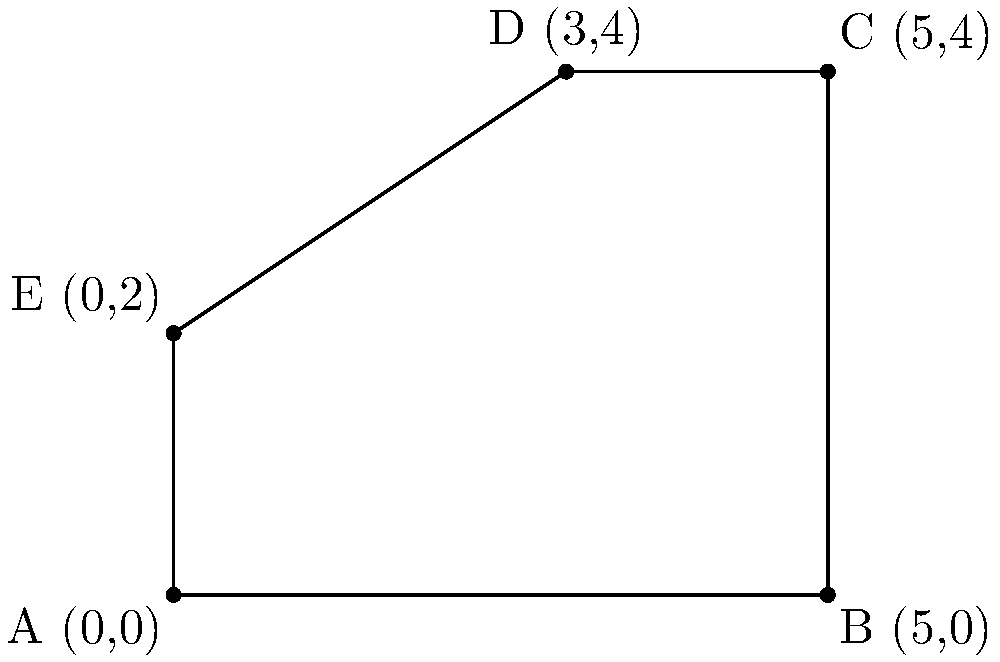As a freelance photographer, you've experienced water damage in your home studio. The insurance adjuster has provided you with a diagram of the affected area, represented by the polygon ABCDE. Calculate the total area of water damage in square meters given the following coordinates:
A(0,0), B(5,0), C(5,4), D(3,4), and E(0,2). To calculate the area of the irregular polygon ABCDE, we can divide it into two parts: a rectangle and a triangle. Let's approach this step-by-step:

1. Identify the rectangle:
   The rectangle is formed by points A, B, D, and the point (3,0) on the x-axis.
   Area of rectangle = length × width
   = 3 × 4 = 12 sq meters

2. Identify the remaining triangle:
   The triangle is formed by points (3,0), B(5,0), and C(5,4).
   
3. Calculate the area of the triangle:
   Area of triangle = $\frac{1}{2}$ × base × height
   Base = 5 - 3 = 2 meters
   Height = 4 meters
   Area of triangle = $\frac{1}{2}$ × 2 × 4 = 4 sq meters

4. Calculate the area of the trapezoid AEDC:
   We can use the formula: Area = $\frac{1}{2}(b_1 + b_2)h$
   where $b_1$ and $b_2$ are the parallel sides and h is the height.
   $b_1$ = 3 (length of DC)
   $b_2$ = 2 (length of AE)
   h = 4 (height from A to D)
   Area of trapezoid = $\frac{1}{2}(3 + 2) × 4 = 10$ sq meters

5. Sum up the total area:
   Total area = Area of rectangle + Area of triangle + Area of trapezoid
               = 12 + 4 + 10 = 26 sq meters

Therefore, the total area of water damage is 26 square meters.
Answer: 26 sq meters 